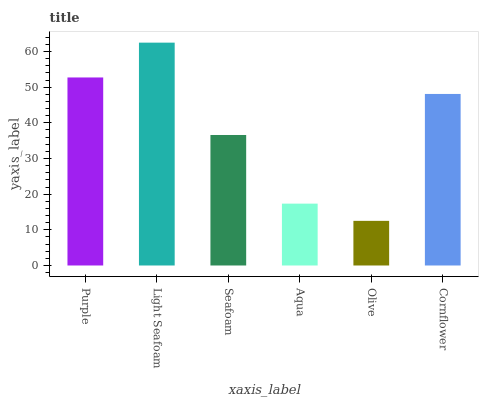Is Olive the minimum?
Answer yes or no. Yes. Is Light Seafoam the maximum?
Answer yes or no. Yes. Is Seafoam the minimum?
Answer yes or no. No. Is Seafoam the maximum?
Answer yes or no. No. Is Light Seafoam greater than Seafoam?
Answer yes or no. Yes. Is Seafoam less than Light Seafoam?
Answer yes or no. Yes. Is Seafoam greater than Light Seafoam?
Answer yes or no. No. Is Light Seafoam less than Seafoam?
Answer yes or no. No. Is Cornflower the high median?
Answer yes or no. Yes. Is Seafoam the low median?
Answer yes or no. Yes. Is Purple the high median?
Answer yes or no. No. Is Aqua the low median?
Answer yes or no. No. 